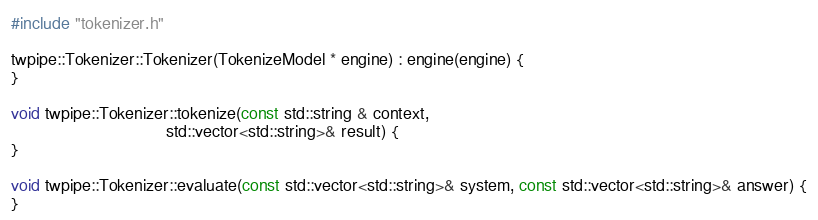<code> <loc_0><loc_0><loc_500><loc_500><_C++_>#include "tokenizer.h"

twpipe::Tokenizer::Tokenizer(TokenizeModel * engine) : engine(engine) {
}

void twpipe::Tokenizer::tokenize(const std::string & context,
                                 std::vector<std::string>& result) {
}

void twpipe::Tokenizer::evaluate(const std::vector<std::string>& system, const std::vector<std::string>& answer) {
}
</code> 